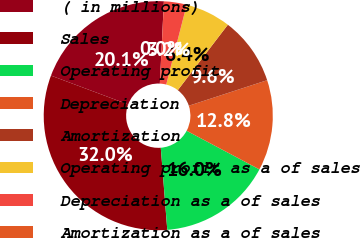Convert chart. <chart><loc_0><loc_0><loc_500><loc_500><pie_chart><fcel>( in millions)<fcel>Sales<fcel>Operating profit<fcel>Depreciation<fcel>Amortization<fcel>Operating profit as a of sales<fcel>Depreciation as a of sales<fcel>Amortization as a of sales<nl><fcel>20.09%<fcel>31.95%<fcel>15.98%<fcel>12.78%<fcel>9.59%<fcel>6.4%<fcel>3.2%<fcel>0.01%<nl></chart> 